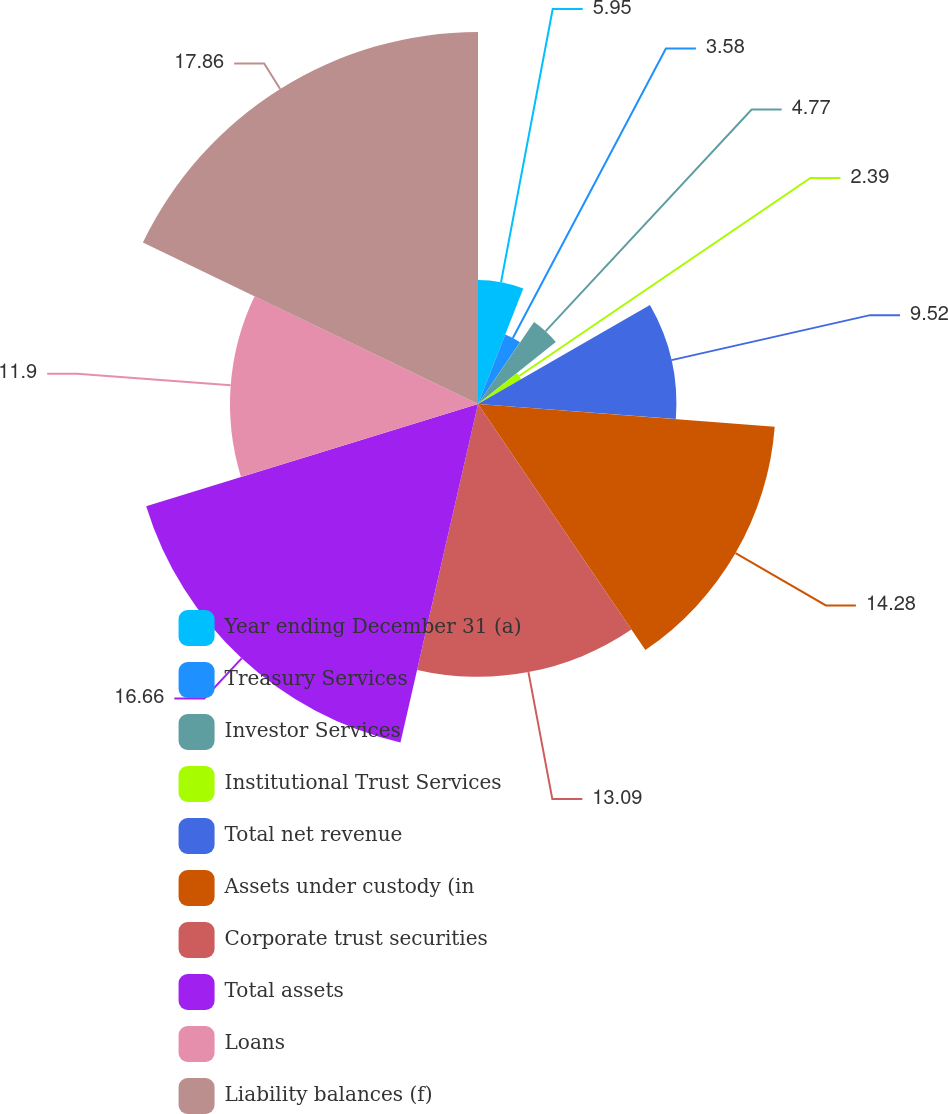<chart> <loc_0><loc_0><loc_500><loc_500><pie_chart><fcel>Year ending December 31 (a)<fcel>Treasury Services<fcel>Investor Services<fcel>Institutional Trust Services<fcel>Total net revenue<fcel>Assets under custody (in<fcel>Corporate trust securities<fcel>Total assets<fcel>Loans<fcel>Liability balances (f)<nl><fcel>5.95%<fcel>3.58%<fcel>4.77%<fcel>2.39%<fcel>9.52%<fcel>14.28%<fcel>13.09%<fcel>16.66%<fcel>11.9%<fcel>17.85%<nl></chart> 